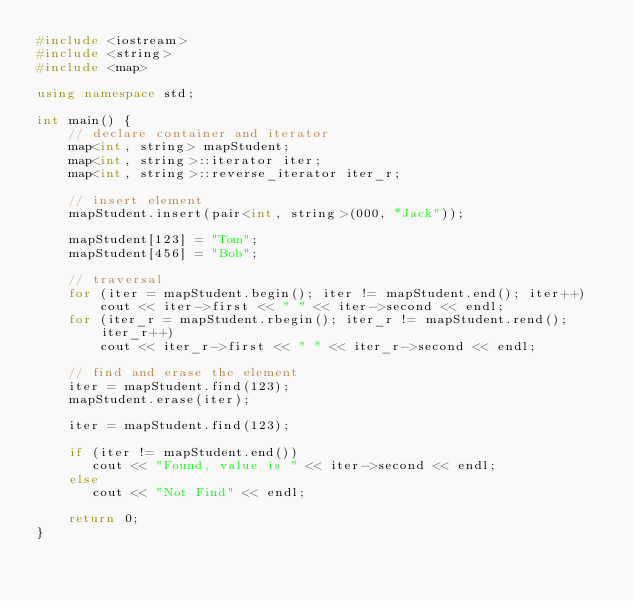<code> <loc_0><loc_0><loc_500><loc_500><_C++_>#include <iostream>
#include <string>
#include <map>

using namespace std;

int main() {
    // declare container and iterator
    map<int, string> mapStudent;
    map<int, string>::iterator iter;
    map<int, string>::reverse_iterator iter_r;

    // insert element
    mapStudent.insert(pair<int, string>(000, "Jack"));

    mapStudent[123] = "Tom";
    mapStudent[456] = "Bob";

    // traversal
    for (iter = mapStudent.begin(); iter != mapStudent.end(); iter++)
        cout << iter->first << " " << iter->second << endl;
    for (iter_r = mapStudent.rbegin(); iter_r != mapStudent.rend(); iter_r++)
        cout << iter_r->first << " " << iter_r->second << endl;

    // find and erase the element
    iter = mapStudent.find(123);
    mapStudent.erase(iter);

    iter = mapStudent.find(123);

    if (iter != mapStudent.end())
       cout << "Found, value is " << iter->second << endl;
    else
       cout << "Not Find" << endl;

    return 0;
}</code> 